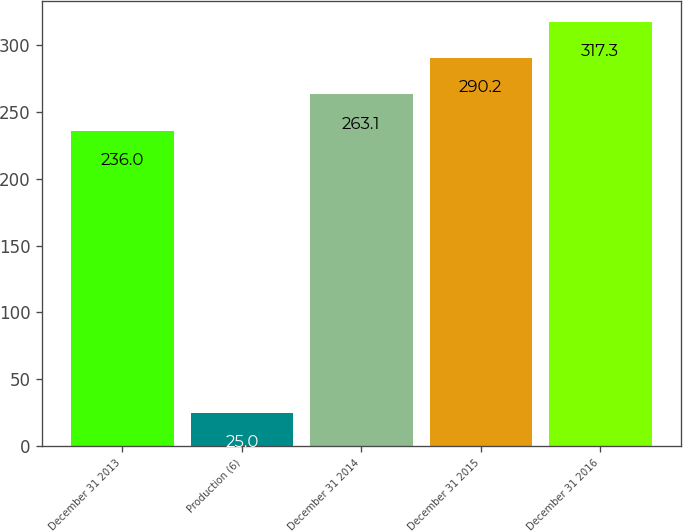Convert chart. <chart><loc_0><loc_0><loc_500><loc_500><bar_chart><fcel>December 31 2013<fcel>Production (6)<fcel>December 31 2014<fcel>December 31 2015<fcel>December 31 2016<nl><fcel>236<fcel>25<fcel>263.1<fcel>290.2<fcel>317.3<nl></chart> 